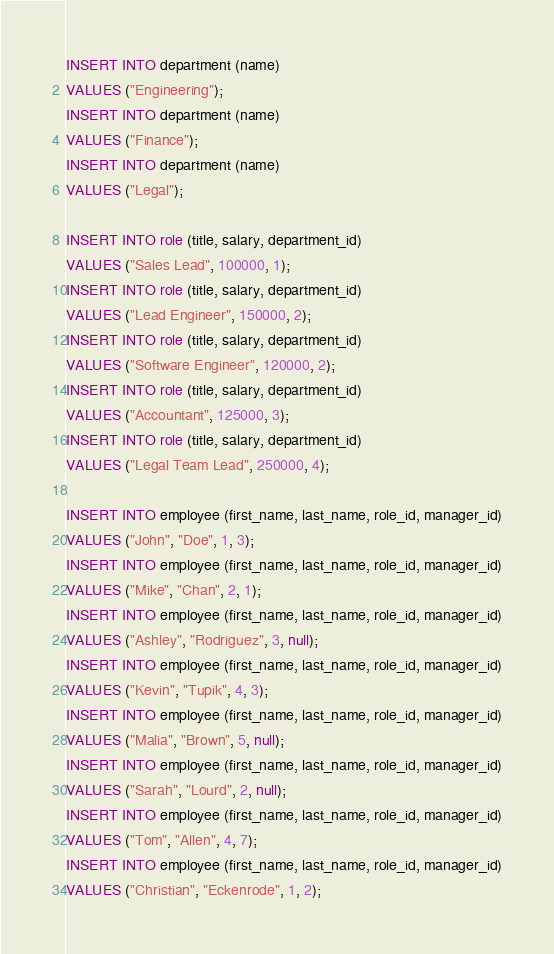Convert code to text. <code><loc_0><loc_0><loc_500><loc_500><_SQL_>INSERT INTO department (name)
VALUES ("Engineering");
INSERT INTO department (name)
VALUES ("Finance");
INSERT INTO department (name)
VALUES ("Legal");

INSERT INTO role (title, salary, department_id)
VALUES ("Sales Lead", 100000, 1);
INSERT INTO role (title, salary, department_id)
VALUES ("Lead Engineer", 150000, 2);
INSERT INTO role (title, salary, department_id)
VALUES ("Software Engineer", 120000, 2);
INSERT INTO role (title, salary, department_id)
VALUES ("Accountant", 125000, 3);
INSERT INTO role (title, salary, department_id)
VALUES ("Legal Team Lead", 250000, 4);

INSERT INTO employee (first_name, last_name, role_id, manager_id)
VALUES ("John", "Doe", 1, 3);
INSERT INTO employee (first_name, last_name, role_id, manager_id)
VALUES ("Mike", "Chan", 2, 1);
INSERT INTO employee (first_name, last_name, role_id, manager_id)
VALUES ("Ashley", "Rodriguez", 3, null);
INSERT INTO employee (first_name, last_name, role_id, manager_id)
VALUES ("Kevin", "Tupik", 4, 3);
INSERT INTO employee (first_name, last_name, role_id, manager_id)
VALUES ("Malia", "Brown", 5, null);
INSERT INTO employee (first_name, last_name, role_id, manager_id)
VALUES ("Sarah", "Lourd", 2, null);
INSERT INTO employee (first_name, last_name, role_id, manager_id)
VALUES ("Tom", "Allen", 4, 7);
INSERT INTO employee (first_name, last_name, role_id, manager_id)
VALUES ("Christian", "Eckenrode", 1, 2);

</code> 